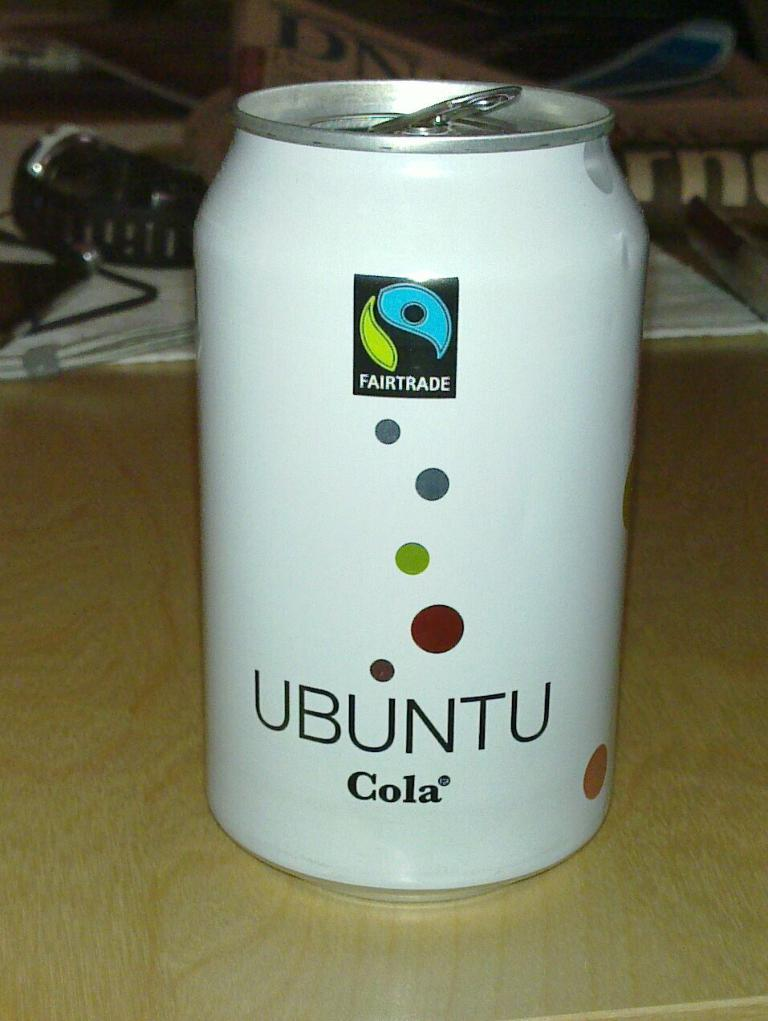<image>
Relay a brief, clear account of the picture shown. A white soda can with polka dots says Ubuntu Cola. 